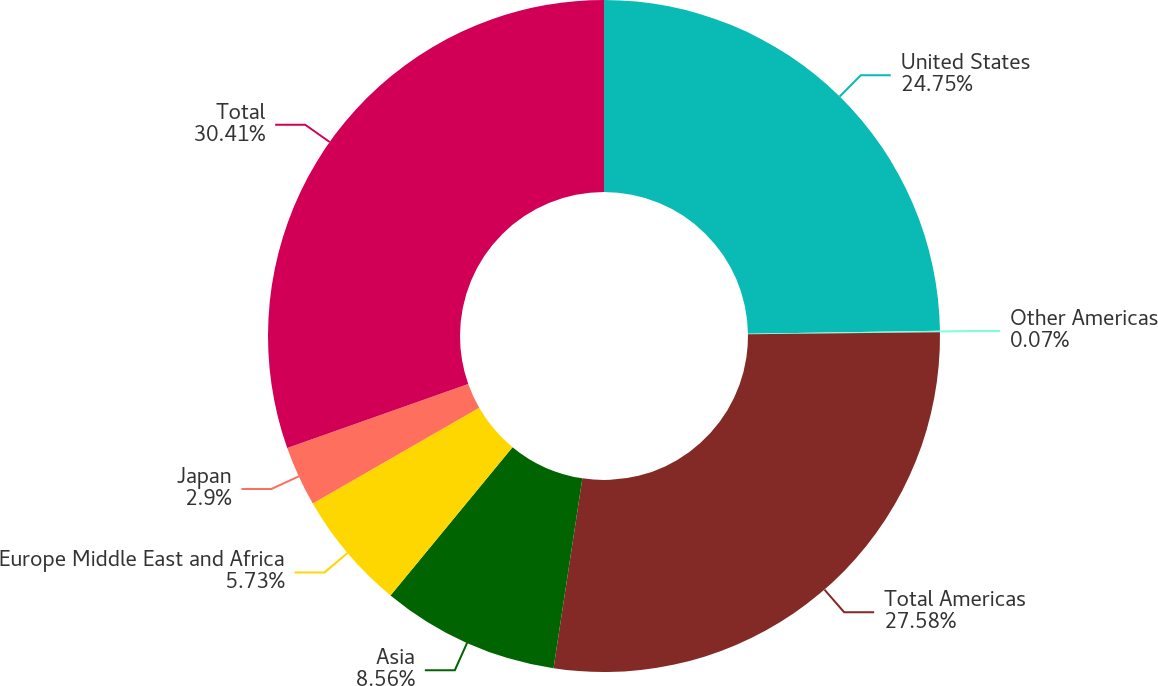Convert chart. <chart><loc_0><loc_0><loc_500><loc_500><pie_chart><fcel>United States<fcel>Other Americas<fcel>Total Americas<fcel>Asia<fcel>Europe Middle East and Africa<fcel>Japan<fcel>Total<nl><fcel>24.75%<fcel>0.07%<fcel>27.58%<fcel>8.56%<fcel>5.73%<fcel>2.9%<fcel>30.41%<nl></chart> 